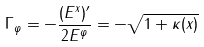Convert formula to latex. <formula><loc_0><loc_0><loc_500><loc_500>\Gamma _ { \varphi } = - \frac { ( E ^ { x } ) ^ { \prime } } { 2 E ^ { \varphi } } = - \sqrt { 1 + \kappa ( x ) }</formula> 